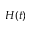Convert formula to latex. <formula><loc_0><loc_0><loc_500><loc_500>H ( t )</formula> 